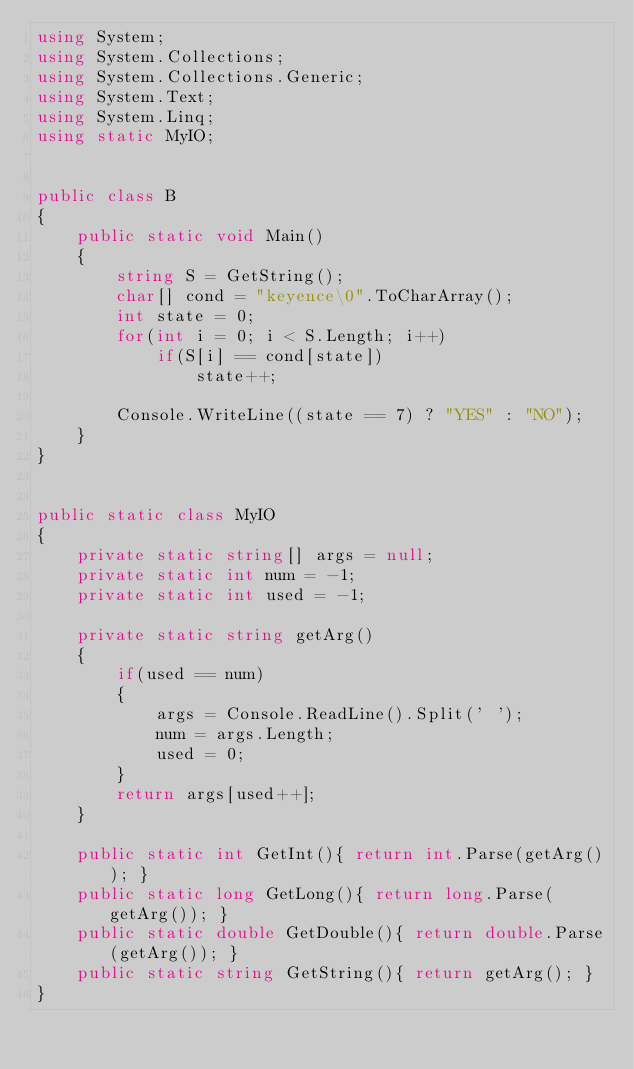<code> <loc_0><loc_0><loc_500><loc_500><_C#_>using System;
using System.Collections;
using System.Collections.Generic;
using System.Text;
using System.Linq;
using static MyIO;


public class B
{
	public static void Main()
	{
		string S = GetString();
		char[] cond = "keyence\0".ToCharArray();
		int state = 0;
		for(int i = 0; i < S.Length; i++)
			if(S[i] == cond[state])
				state++;

		Console.WriteLine((state == 7) ? "YES" : "NO");
	}
}


public static class MyIO
{
	private static string[] args = null;
	private static int num = -1;
	private static int used = -1;

	private static string getArg()
	{
		if(used == num)
		{
			args = Console.ReadLine().Split(' ');
			num = args.Length;
			used = 0;
		}
		return args[used++];
	}

	public static int GetInt(){ return int.Parse(getArg()); }
	public static long GetLong(){ return long.Parse(getArg()); }
	public static double GetDouble(){ return double.Parse(getArg()); }
	public static string GetString(){ return getArg(); }
}
</code> 